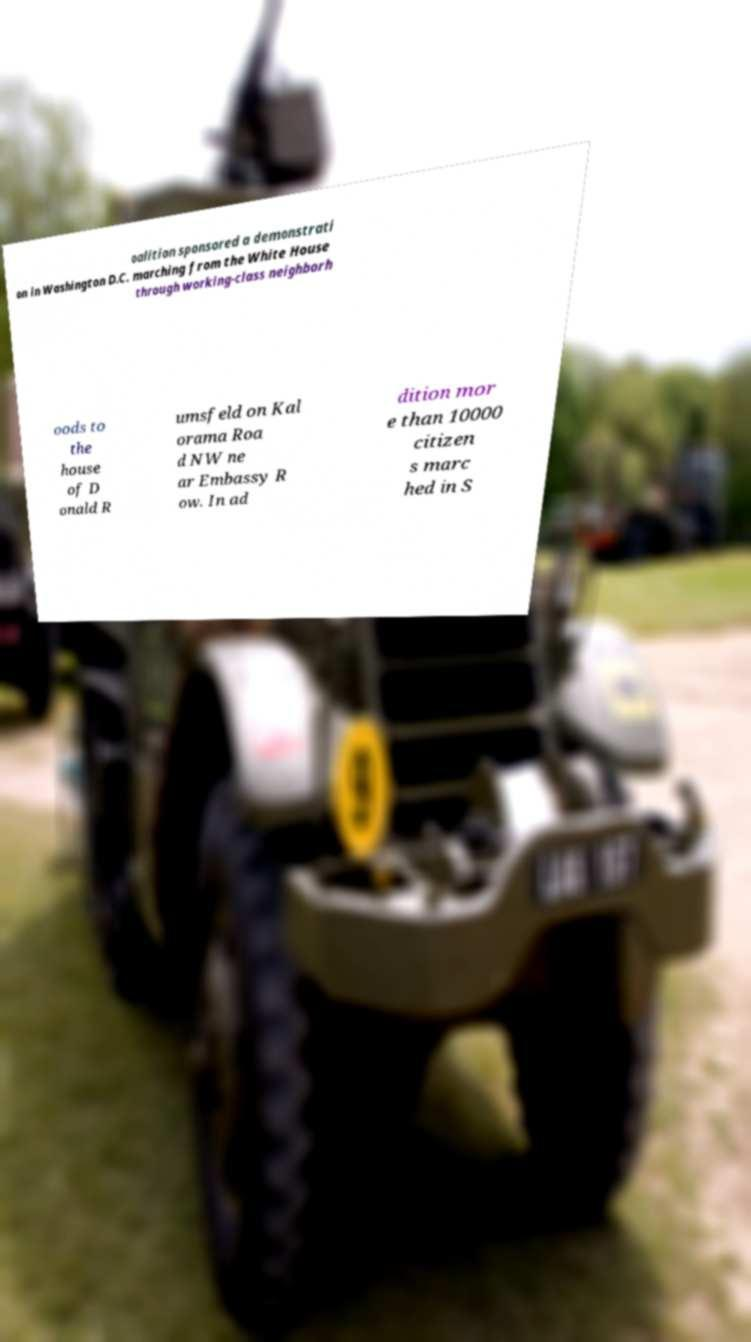I need the written content from this picture converted into text. Can you do that? oalition sponsored a demonstrati on in Washington D.C. marching from the White House through working-class neighborh oods to the house of D onald R umsfeld on Kal orama Roa d NW ne ar Embassy R ow. In ad dition mor e than 10000 citizen s marc hed in S 